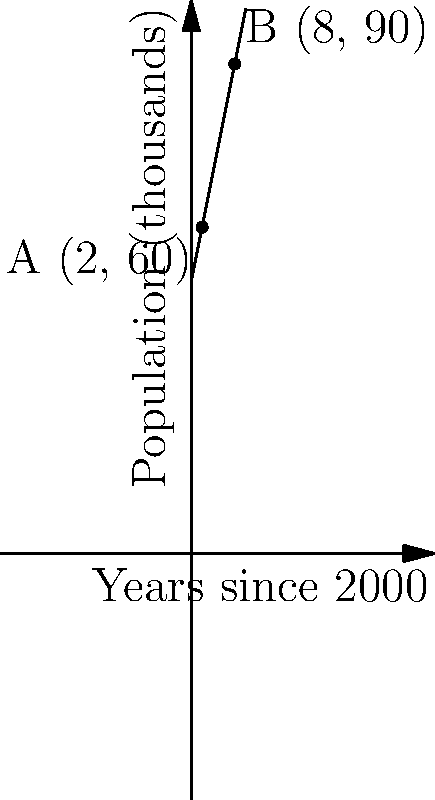As a supportive figure in town, you're analyzing population growth data for different areas. The graph shows population growth over time, with point A representing the downtown area and point B representing the suburbs. Calculate the slope of the line connecting these two points to determine the relative growth rate between these areas from 2002 to 2008. To find the slope of the line connecting two points, we use the slope formula:

$$ m = \frac{y_2 - y_1}{x_2 - x_1} $$

Where $(x_1, y_1)$ is the first point and $(x_2, y_2)$ is the second point.

From the graph:
Point A: $(2, 60)$
Point B: $(8, 90)$

Let's plug these values into the formula:

$$ m = \frac{90 - 60}{8 - 2} = \frac{30}{6} $$

Simplify:

$$ m = 5 $$

This slope represents the average increase in population (in thousands) per year between the two areas from 2002 to 2008.
Answer: 5 